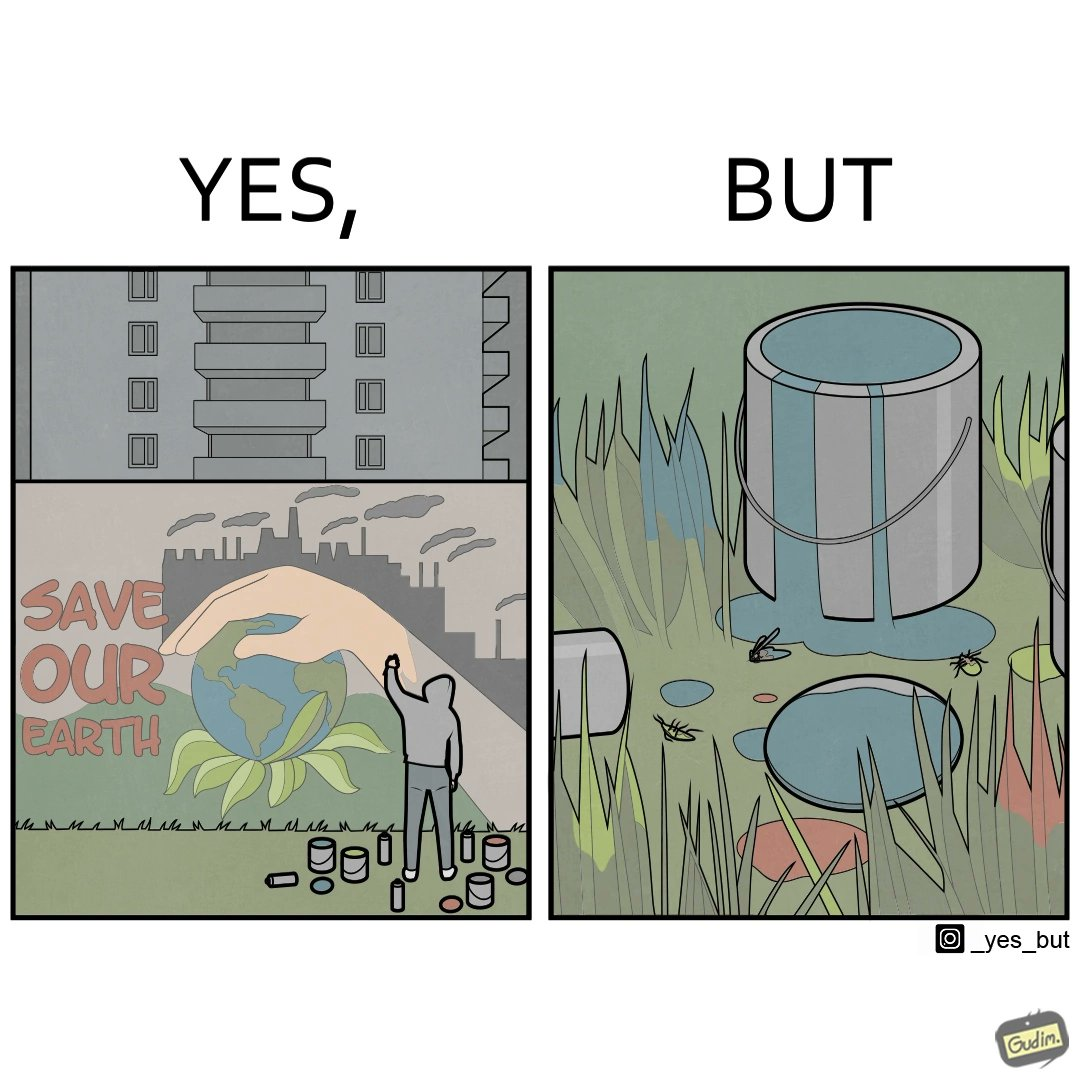Would you classify this image as satirical? Yes, this image is satirical. 